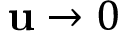<formula> <loc_0><loc_0><loc_500><loc_500>u \to 0</formula> 